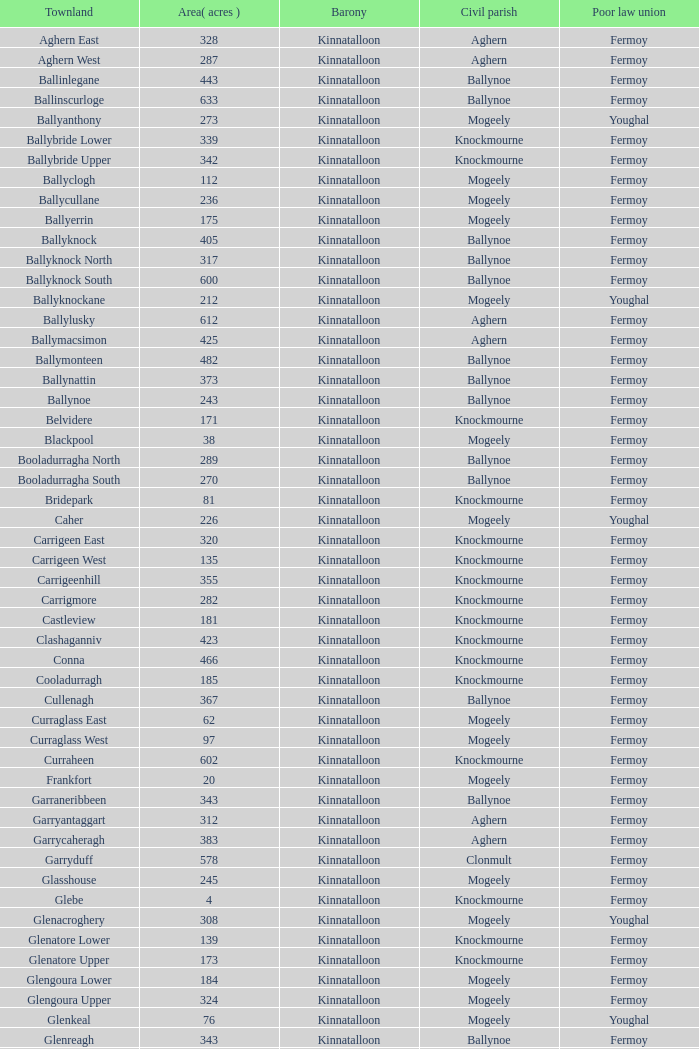Name  the townland for fermoy and ballynoe Ballinlegane, Ballinscurloge, Ballyknock, Ballyknock North, Ballyknock South, Ballymonteen, Ballynattin, Ballynoe, Booladurragha North, Booladurragha South, Cullenagh, Garraneribbeen, Glenreagh, Glentane, Killasseragh, Kilphillibeen, Knockakeo, Longueville North, Longueville South, Rathdrum, Shanaboola. 